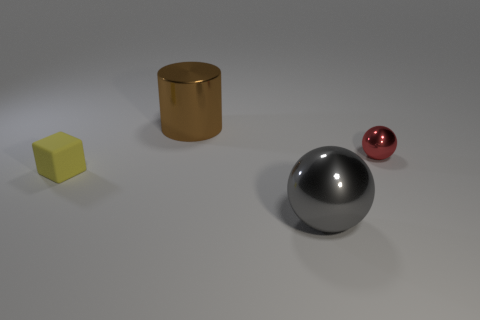The object that is both in front of the tiny sphere and behind the gray metallic object has what shape?
Keep it short and to the point. Cube. The metal thing that is the same size as the gray metallic ball is what color?
Ensure brevity in your answer.  Brown. There is a metal sphere in front of the tiny metal ball; is it the same size as the thing behind the red metallic sphere?
Give a very brief answer. Yes. How big is the metallic thing that is behind the ball to the right of the large thing that is in front of the cube?
Make the answer very short. Large. There is a metallic thing that is behind the metallic sphere behind the gray sphere; what shape is it?
Keep it short and to the point. Cylinder. There is a thing that is behind the tiny yellow object and to the left of the small red thing; what is its color?
Provide a succinct answer. Brown. Is there a gray thing that has the same material as the large brown object?
Your answer should be very brief. Yes. How big is the cylinder?
Your response must be concise. Large. There is a shiny object that is to the left of the sphere that is in front of the yellow block; what is its size?
Keep it short and to the point. Large. How many cyan cylinders are there?
Keep it short and to the point. 0. 